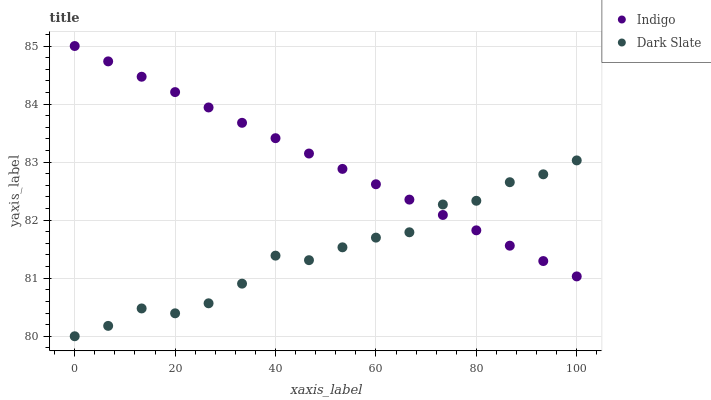Does Dark Slate have the minimum area under the curve?
Answer yes or no. Yes. Does Indigo have the maximum area under the curve?
Answer yes or no. Yes. Does Indigo have the minimum area under the curve?
Answer yes or no. No. Is Indigo the smoothest?
Answer yes or no. Yes. Is Dark Slate the roughest?
Answer yes or no. Yes. Is Indigo the roughest?
Answer yes or no. No. Does Dark Slate have the lowest value?
Answer yes or no. Yes. Does Indigo have the lowest value?
Answer yes or no. No. Does Indigo have the highest value?
Answer yes or no. Yes. Does Dark Slate intersect Indigo?
Answer yes or no. Yes. Is Dark Slate less than Indigo?
Answer yes or no. No. Is Dark Slate greater than Indigo?
Answer yes or no. No. 